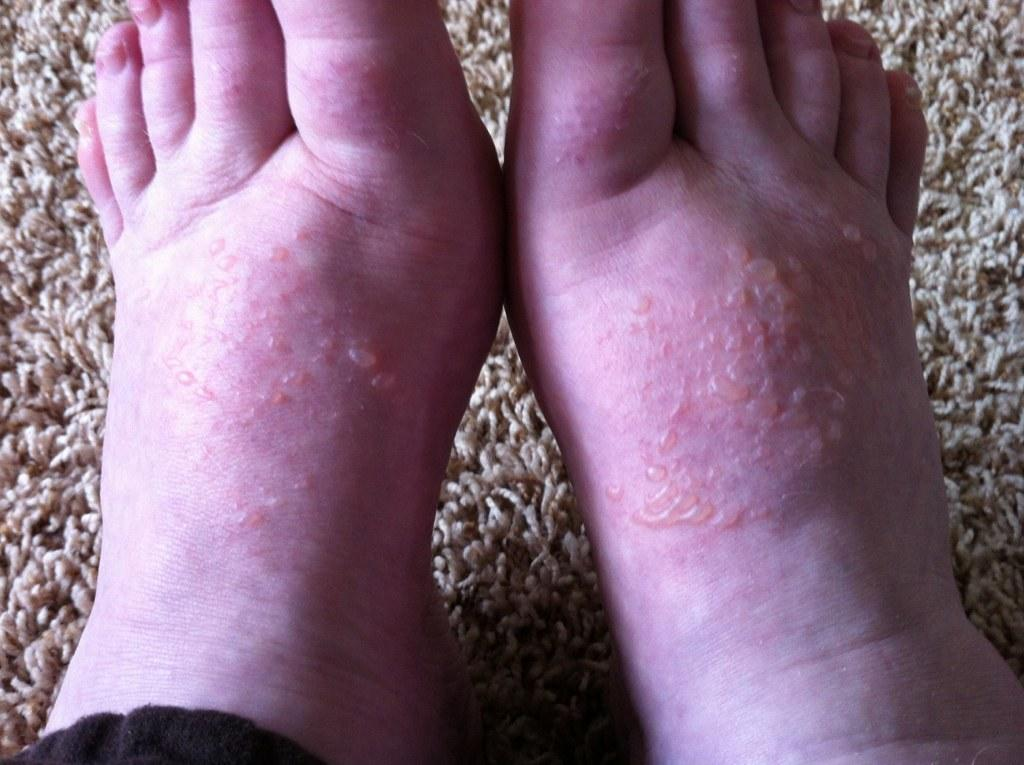What is visible in the image related to human body parts? There are two legs in the image. What is the condition of the legs in the image? The legs have burns on them. How many people are standing on the island in the image? There is no island present in the image, and therefore no people standing on it. What is the chance of the crowd dispersing in the image? There is no crowd present in the image, so it is not possible to determine the chance of the crowd dispersing. 